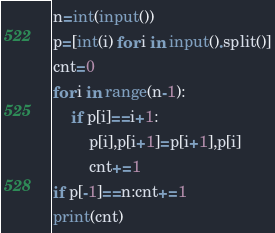Convert code to text. <code><loc_0><loc_0><loc_500><loc_500><_Python_>n=int(input())
p=[int(i) for i in input().split()]
cnt=0
for i in range(n-1):
	if p[i]==i+1:
		p[i],p[i+1]=p[i+1],p[i]
		cnt+=1
if p[-1]==n:cnt+=1
print(cnt)</code> 